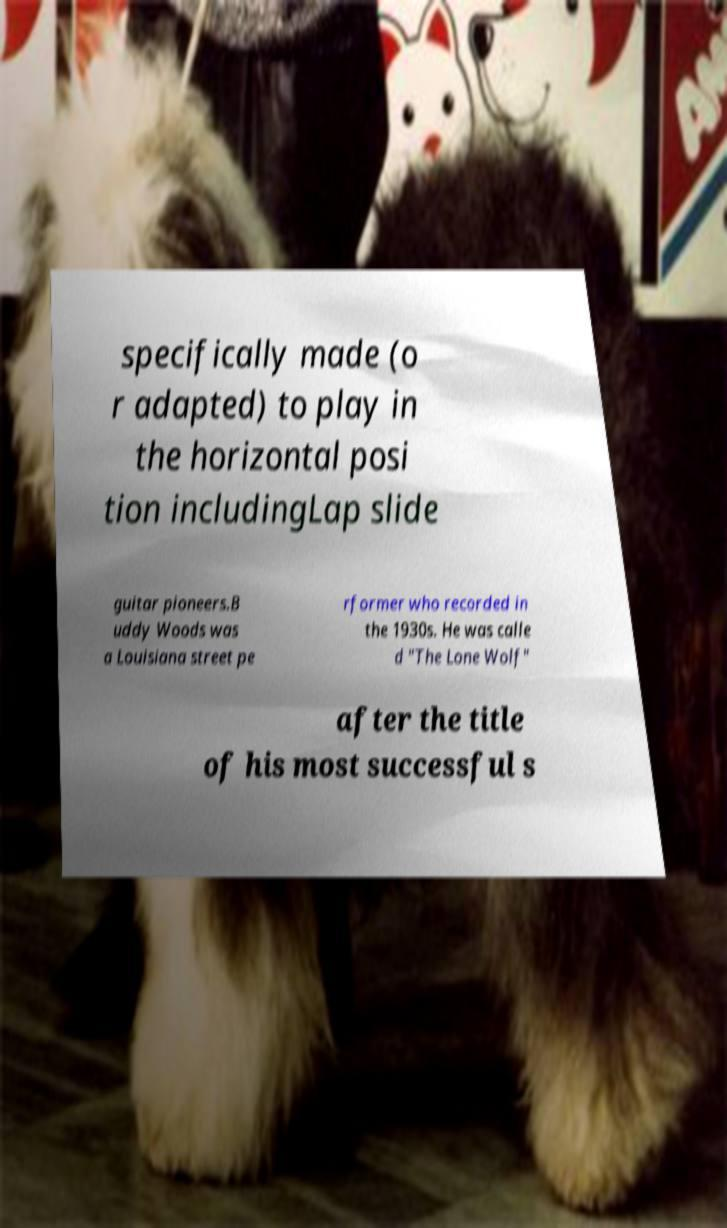Can you accurately transcribe the text from the provided image for me? specifically made (o r adapted) to play in the horizontal posi tion includingLap slide guitar pioneers.B uddy Woods was a Louisiana street pe rformer who recorded in the 1930s. He was calle d "The Lone Wolf" after the title of his most successful s 